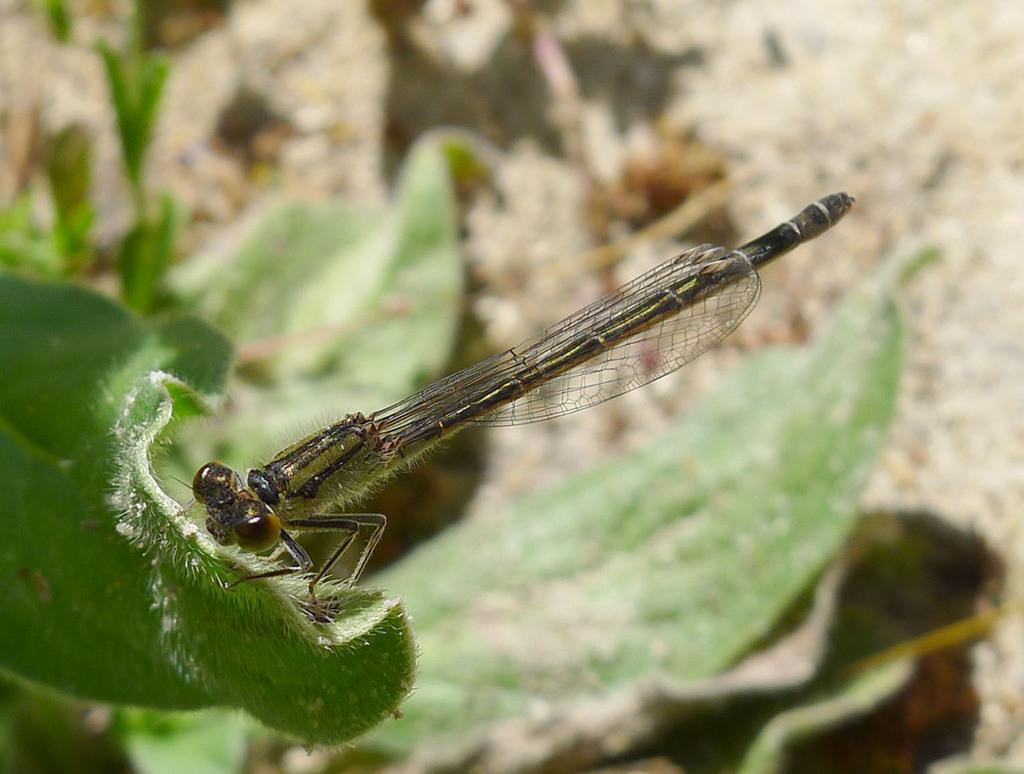Describe this image in one or two sentences. In the center of the image there is a insect in the leaf. At the bottom of the image there is ground. 